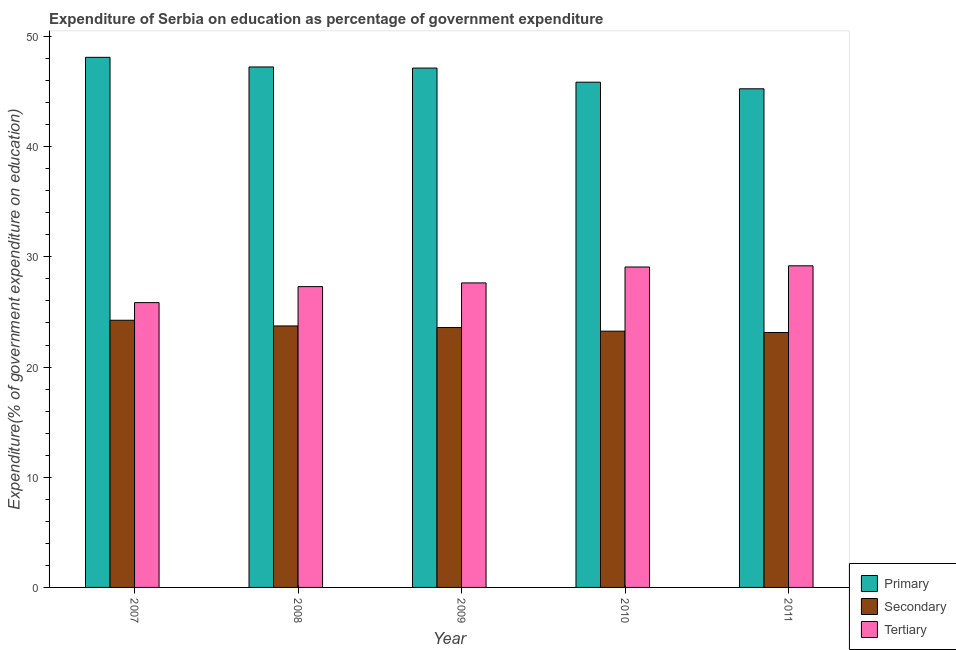How many different coloured bars are there?
Offer a very short reply. 3. Are the number of bars on each tick of the X-axis equal?
Offer a very short reply. Yes. How many bars are there on the 1st tick from the left?
Keep it short and to the point. 3. In how many cases, is the number of bars for a given year not equal to the number of legend labels?
Offer a very short reply. 0. What is the expenditure on tertiary education in 2007?
Offer a terse response. 25.85. Across all years, what is the maximum expenditure on primary education?
Your answer should be very brief. 48.11. Across all years, what is the minimum expenditure on secondary education?
Keep it short and to the point. 23.14. What is the total expenditure on tertiary education in the graph?
Your response must be concise. 139.06. What is the difference between the expenditure on tertiary education in 2008 and that in 2010?
Your answer should be very brief. -1.78. What is the difference between the expenditure on secondary education in 2011 and the expenditure on tertiary education in 2009?
Your answer should be very brief. -0.45. What is the average expenditure on primary education per year?
Offer a terse response. 46.72. In how many years, is the expenditure on secondary education greater than 38 %?
Offer a very short reply. 0. What is the ratio of the expenditure on primary education in 2007 to that in 2010?
Ensure brevity in your answer.  1.05. Is the expenditure on tertiary education in 2008 less than that in 2009?
Provide a succinct answer. Yes. Is the difference between the expenditure on secondary education in 2007 and 2011 greater than the difference between the expenditure on tertiary education in 2007 and 2011?
Keep it short and to the point. No. What is the difference between the highest and the second highest expenditure on primary education?
Keep it short and to the point. 0.87. What is the difference between the highest and the lowest expenditure on tertiary education?
Make the answer very short. 3.34. Is the sum of the expenditure on tertiary education in 2009 and 2011 greater than the maximum expenditure on secondary education across all years?
Provide a short and direct response. Yes. What does the 3rd bar from the left in 2011 represents?
Give a very brief answer. Tertiary. What does the 2nd bar from the right in 2009 represents?
Make the answer very short. Secondary. How many bars are there?
Provide a succinct answer. 15. How many years are there in the graph?
Provide a short and direct response. 5. What is the difference between two consecutive major ticks on the Y-axis?
Give a very brief answer. 10. Are the values on the major ticks of Y-axis written in scientific E-notation?
Provide a succinct answer. No. Does the graph contain any zero values?
Make the answer very short. No. Does the graph contain grids?
Your response must be concise. No. What is the title of the graph?
Keep it short and to the point. Expenditure of Serbia on education as percentage of government expenditure. What is the label or title of the X-axis?
Offer a terse response. Year. What is the label or title of the Y-axis?
Provide a short and direct response. Expenditure(% of government expenditure on education). What is the Expenditure(% of government expenditure on education) in Primary in 2007?
Your answer should be compact. 48.11. What is the Expenditure(% of government expenditure on education) in Secondary in 2007?
Ensure brevity in your answer.  24.25. What is the Expenditure(% of government expenditure on education) in Tertiary in 2007?
Your answer should be compact. 25.85. What is the Expenditure(% of government expenditure on education) of Primary in 2008?
Keep it short and to the point. 47.24. What is the Expenditure(% of government expenditure on education) in Secondary in 2008?
Provide a short and direct response. 23.73. What is the Expenditure(% of government expenditure on education) of Tertiary in 2008?
Ensure brevity in your answer.  27.3. What is the Expenditure(% of government expenditure on education) in Primary in 2009?
Your answer should be compact. 47.14. What is the Expenditure(% of government expenditure on education) of Secondary in 2009?
Your answer should be compact. 23.59. What is the Expenditure(% of government expenditure on education) in Tertiary in 2009?
Offer a terse response. 27.64. What is the Expenditure(% of government expenditure on education) in Primary in 2010?
Your answer should be very brief. 45.86. What is the Expenditure(% of government expenditure on education) of Secondary in 2010?
Give a very brief answer. 23.26. What is the Expenditure(% of government expenditure on education) of Tertiary in 2010?
Offer a terse response. 29.08. What is the Expenditure(% of government expenditure on education) of Primary in 2011?
Make the answer very short. 45.26. What is the Expenditure(% of government expenditure on education) in Secondary in 2011?
Provide a succinct answer. 23.14. What is the Expenditure(% of government expenditure on education) of Tertiary in 2011?
Offer a terse response. 29.19. Across all years, what is the maximum Expenditure(% of government expenditure on education) of Primary?
Provide a succinct answer. 48.11. Across all years, what is the maximum Expenditure(% of government expenditure on education) in Secondary?
Provide a short and direct response. 24.25. Across all years, what is the maximum Expenditure(% of government expenditure on education) of Tertiary?
Your response must be concise. 29.19. Across all years, what is the minimum Expenditure(% of government expenditure on education) in Primary?
Offer a very short reply. 45.26. Across all years, what is the minimum Expenditure(% of government expenditure on education) in Secondary?
Offer a terse response. 23.14. Across all years, what is the minimum Expenditure(% of government expenditure on education) in Tertiary?
Provide a short and direct response. 25.85. What is the total Expenditure(% of government expenditure on education) of Primary in the graph?
Provide a succinct answer. 233.6. What is the total Expenditure(% of government expenditure on education) of Secondary in the graph?
Provide a short and direct response. 117.96. What is the total Expenditure(% of government expenditure on education) in Tertiary in the graph?
Provide a succinct answer. 139.06. What is the difference between the Expenditure(% of government expenditure on education) in Primary in 2007 and that in 2008?
Give a very brief answer. 0.87. What is the difference between the Expenditure(% of government expenditure on education) of Secondary in 2007 and that in 2008?
Offer a terse response. 0.52. What is the difference between the Expenditure(% of government expenditure on education) of Tertiary in 2007 and that in 2008?
Offer a terse response. -1.45. What is the difference between the Expenditure(% of government expenditure on education) of Primary in 2007 and that in 2009?
Your response must be concise. 0.98. What is the difference between the Expenditure(% of government expenditure on education) in Secondary in 2007 and that in 2009?
Provide a succinct answer. 0.66. What is the difference between the Expenditure(% of government expenditure on education) of Tertiary in 2007 and that in 2009?
Ensure brevity in your answer.  -1.79. What is the difference between the Expenditure(% of government expenditure on education) of Primary in 2007 and that in 2010?
Offer a terse response. 2.26. What is the difference between the Expenditure(% of government expenditure on education) in Secondary in 2007 and that in 2010?
Keep it short and to the point. 0.99. What is the difference between the Expenditure(% of government expenditure on education) in Tertiary in 2007 and that in 2010?
Offer a terse response. -3.23. What is the difference between the Expenditure(% of government expenditure on education) in Primary in 2007 and that in 2011?
Your answer should be compact. 2.86. What is the difference between the Expenditure(% of government expenditure on education) of Secondary in 2007 and that in 2011?
Make the answer very short. 1.11. What is the difference between the Expenditure(% of government expenditure on education) in Tertiary in 2007 and that in 2011?
Your answer should be very brief. -3.34. What is the difference between the Expenditure(% of government expenditure on education) in Primary in 2008 and that in 2009?
Your response must be concise. 0.1. What is the difference between the Expenditure(% of government expenditure on education) in Secondary in 2008 and that in 2009?
Offer a terse response. 0.14. What is the difference between the Expenditure(% of government expenditure on education) of Tertiary in 2008 and that in 2009?
Offer a terse response. -0.34. What is the difference between the Expenditure(% of government expenditure on education) in Primary in 2008 and that in 2010?
Your answer should be very brief. 1.38. What is the difference between the Expenditure(% of government expenditure on education) in Secondary in 2008 and that in 2010?
Offer a terse response. 0.47. What is the difference between the Expenditure(% of government expenditure on education) in Tertiary in 2008 and that in 2010?
Provide a short and direct response. -1.78. What is the difference between the Expenditure(% of government expenditure on education) in Primary in 2008 and that in 2011?
Give a very brief answer. 1.98. What is the difference between the Expenditure(% of government expenditure on education) in Secondary in 2008 and that in 2011?
Ensure brevity in your answer.  0.59. What is the difference between the Expenditure(% of government expenditure on education) in Tertiary in 2008 and that in 2011?
Ensure brevity in your answer.  -1.89. What is the difference between the Expenditure(% of government expenditure on education) in Primary in 2009 and that in 2010?
Provide a short and direct response. 1.28. What is the difference between the Expenditure(% of government expenditure on education) in Secondary in 2009 and that in 2010?
Your response must be concise. 0.33. What is the difference between the Expenditure(% of government expenditure on education) in Tertiary in 2009 and that in 2010?
Your answer should be compact. -1.44. What is the difference between the Expenditure(% of government expenditure on education) in Primary in 2009 and that in 2011?
Ensure brevity in your answer.  1.88. What is the difference between the Expenditure(% of government expenditure on education) in Secondary in 2009 and that in 2011?
Provide a short and direct response. 0.45. What is the difference between the Expenditure(% of government expenditure on education) of Tertiary in 2009 and that in 2011?
Provide a succinct answer. -1.55. What is the difference between the Expenditure(% of government expenditure on education) in Primary in 2010 and that in 2011?
Provide a short and direct response. 0.6. What is the difference between the Expenditure(% of government expenditure on education) in Secondary in 2010 and that in 2011?
Provide a succinct answer. 0.12. What is the difference between the Expenditure(% of government expenditure on education) of Tertiary in 2010 and that in 2011?
Your response must be concise. -0.11. What is the difference between the Expenditure(% of government expenditure on education) of Primary in 2007 and the Expenditure(% of government expenditure on education) of Secondary in 2008?
Offer a terse response. 24.38. What is the difference between the Expenditure(% of government expenditure on education) in Primary in 2007 and the Expenditure(% of government expenditure on education) in Tertiary in 2008?
Keep it short and to the point. 20.81. What is the difference between the Expenditure(% of government expenditure on education) of Secondary in 2007 and the Expenditure(% of government expenditure on education) of Tertiary in 2008?
Your answer should be very brief. -3.05. What is the difference between the Expenditure(% of government expenditure on education) of Primary in 2007 and the Expenditure(% of government expenditure on education) of Secondary in 2009?
Keep it short and to the point. 24.52. What is the difference between the Expenditure(% of government expenditure on education) of Primary in 2007 and the Expenditure(% of government expenditure on education) of Tertiary in 2009?
Your response must be concise. 20.47. What is the difference between the Expenditure(% of government expenditure on education) of Secondary in 2007 and the Expenditure(% of government expenditure on education) of Tertiary in 2009?
Provide a short and direct response. -3.39. What is the difference between the Expenditure(% of government expenditure on education) of Primary in 2007 and the Expenditure(% of government expenditure on education) of Secondary in 2010?
Your response must be concise. 24.85. What is the difference between the Expenditure(% of government expenditure on education) in Primary in 2007 and the Expenditure(% of government expenditure on education) in Tertiary in 2010?
Keep it short and to the point. 19.03. What is the difference between the Expenditure(% of government expenditure on education) of Secondary in 2007 and the Expenditure(% of government expenditure on education) of Tertiary in 2010?
Offer a terse response. -4.83. What is the difference between the Expenditure(% of government expenditure on education) of Primary in 2007 and the Expenditure(% of government expenditure on education) of Secondary in 2011?
Keep it short and to the point. 24.97. What is the difference between the Expenditure(% of government expenditure on education) of Primary in 2007 and the Expenditure(% of government expenditure on education) of Tertiary in 2011?
Your answer should be compact. 18.92. What is the difference between the Expenditure(% of government expenditure on education) of Secondary in 2007 and the Expenditure(% of government expenditure on education) of Tertiary in 2011?
Provide a succinct answer. -4.94. What is the difference between the Expenditure(% of government expenditure on education) in Primary in 2008 and the Expenditure(% of government expenditure on education) in Secondary in 2009?
Make the answer very short. 23.65. What is the difference between the Expenditure(% of government expenditure on education) of Primary in 2008 and the Expenditure(% of government expenditure on education) of Tertiary in 2009?
Provide a short and direct response. 19.6. What is the difference between the Expenditure(% of government expenditure on education) in Secondary in 2008 and the Expenditure(% of government expenditure on education) in Tertiary in 2009?
Ensure brevity in your answer.  -3.91. What is the difference between the Expenditure(% of government expenditure on education) in Primary in 2008 and the Expenditure(% of government expenditure on education) in Secondary in 2010?
Ensure brevity in your answer.  23.98. What is the difference between the Expenditure(% of government expenditure on education) of Primary in 2008 and the Expenditure(% of government expenditure on education) of Tertiary in 2010?
Your response must be concise. 18.16. What is the difference between the Expenditure(% of government expenditure on education) in Secondary in 2008 and the Expenditure(% of government expenditure on education) in Tertiary in 2010?
Make the answer very short. -5.35. What is the difference between the Expenditure(% of government expenditure on education) in Primary in 2008 and the Expenditure(% of government expenditure on education) in Secondary in 2011?
Provide a succinct answer. 24.1. What is the difference between the Expenditure(% of government expenditure on education) of Primary in 2008 and the Expenditure(% of government expenditure on education) of Tertiary in 2011?
Your answer should be very brief. 18.05. What is the difference between the Expenditure(% of government expenditure on education) of Secondary in 2008 and the Expenditure(% of government expenditure on education) of Tertiary in 2011?
Offer a terse response. -5.46. What is the difference between the Expenditure(% of government expenditure on education) in Primary in 2009 and the Expenditure(% of government expenditure on education) in Secondary in 2010?
Provide a short and direct response. 23.88. What is the difference between the Expenditure(% of government expenditure on education) of Primary in 2009 and the Expenditure(% of government expenditure on education) of Tertiary in 2010?
Provide a succinct answer. 18.05. What is the difference between the Expenditure(% of government expenditure on education) of Secondary in 2009 and the Expenditure(% of government expenditure on education) of Tertiary in 2010?
Keep it short and to the point. -5.49. What is the difference between the Expenditure(% of government expenditure on education) of Primary in 2009 and the Expenditure(% of government expenditure on education) of Secondary in 2011?
Make the answer very short. 24. What is the difference between the Expenditure(% of government expenditure on education) of Primary in 2009 and the Expenditure(% of government expenditure on education) of Tertiary in 2011?
Ensure brevity in your answer.  17.95. What is the difference between the Expenditure(% of government expenditure on education) in Secondary in 2009 and the Expenditure(% of government expenditure on education) in Tertiary in 2011?
Give a very brief answer. -5.6. What is the difference between the Expenditure(% of government expenditure on education) in Primary in 2010 and the Expenditure(% of government expenditure on education) in Secondary in 2011?
Ensure brevity in your answer.  22.72. What is the difference between the Expenditure(% of government expenditure on education) in Primary in 2010 and the Expenditure(% of government expenditure on education) in Tertiary in 2011?
Provide a short and direct response. 16.66. What is the difference between the Expenditure(% of government expenditure on education) of Secondary in 2010 and the Expenditure(% of government expenditure on education) of Tertiary in 2011?
Provide a succinct answer. -5.93. What is the average Expenditure(% of government expenditure on education) in Primary per year?
Ensure brevity in your answer.  46.72. What is the average Expenditure(% of government expenditure on education) in Secondary per year?
Your answer should be very brief. 23.59. What is the average Expenditure(% of government expenditure on education) in Tertiary per year?
Offer a terse response. 27.81. In the year 2007, what is the difference between the Expenditure(% of government expenditure on education) of Primary and Expenditure(% of government expenditure on education) of Secondary?
Give a very brief answer. 23.86. In the year 2007, what is the difference between the Expenditure(% of government expenditure on education) in Primary and Expenditure(% of government expenditure on education) in Tertiary?
Offer a terse response. 22.26. In the year 2007, what is the difference between the Expenditure(% of government expenditure on education) of Secondary and Expenditure(% of government expenditure on education) of Tertiary?
Your response must be concise. -1.6. In the year 2008, what is the difference between the Expenditure(% of government expenditure on education) in Primary and Expenditure(% of government expenditure on education) in Secondary?
Provide a succinct answer. 23.51. In the year 2008, what is the difference between the Expenditure(% of government expenditure on education) of Primary and Expenditure(% of government expenditure on education) of Tertiary?
Your response must be concise. 19.94. In the year 2008, what is the difference between the Expenditure(% of government expenditure on education) of Secondary and Expenditure(% of government expenditure on education) of Tertiary?
Keep it short and to the point. -3.57. In the year 2009, what is the difference between the Expenditure(% of government expenditure on education) in Primary and Expenditure(% of government expenditure on education) in Secondary?
Your response must be concise. 23.55. In the year 2009, what is the difference between the Expenditure(% of government expenditure on education) in Primary and Expenditure(% of government expenditure on education) in Tertiary?
Offer a terse response. 19.5. In the year 2009, what is the difference between the Expenditure(% of government expenditure on education) in Secondary and Expenditure(% of government expenditure on education) in Tertiary?
Give a very brief answer. -4.05. In the year 2010, what is the difference between the Expenditure(% of government expenditure on education) of Primary and Expenditure(% of government expenditure on education) of Secondary?
Your response must be concise. 22.6. In the year 2010, what is the difference between the Expenditure(% of government expenditure on education) in Primary and Expenditure(% of government expenditure on education) in Tertiary?
Provide a succinct answer. 16.77. In the year 2010, what is the difference between the Expenditure(% of government expenditure on education) in Secondary and Expenditure(% of government expenditure on education) in Tertiary?
Your answer should be compact. -5.82. In the year 2011, what is the difference between the Expenditure(% of government expenditure on education) of Primary and Expenditure(% of government expenditure on education) of Secondary?
Offer a very short reply. 22.12. In the year 2011, what is the difference between the Expenditure(% of government expenditure on education) in Primary and Expenditure(% of government expenditure on education) in Tertiary?
Your answer should be very brief. 16.07. In the year 2011, what is the difference between the Expenditure(% of government expenditure on education) in Secondary and Expenditure(% of government expenditure on education) in Tertiary?
Ensure brevity in your answer.  -6.05. What is the ratio of the Expenditure(% of government expenditure on education) of Primary in 2007 to that in 2008?
Make the answer very short. 1.02. What is the ratio of the Expenditure(% of government expenditure on education) in Secondary in 2007 to that in 2008?
Give a very brief answer. 1.02. What is the ratio of the Expenditure(% of government expenditure on education) in Tertiary in 2007 to that in 2008?
Give a very brief answer. 0.95. What is the ratio of the Expenditure(% of government expenditure on education) in Primary in 2007 to that in 2009?
Offer a very short reply. 1.02. What is the ratio of the Expenditure(% of government expenditure on education) in Secondary in 2007 to that in 2009?
Provide a short and direct response. 1.03. What is the ratio of the Expenditure(% of government expenditure on education) in Tertiary in 2007 to that in 2009?
Your answer should be very brief. 0.94. What is the ratio of the Expenditure(% of government expenditure on education) in Primary in 2007 to that in 2010?
Provide a succinct answer. 1.05. What is the ratio of the Expenditure(% of government expenditure on education) in Secondary in 2007 to that in 2010?
Provide a short and direct response. 1.04. What is the ratio of the Expenditure(% of government expenditure on education) of Tertiary in 2007 to that in 2010?
Your response must be concise. 0.89. What is the ratio of the Expenditure(% of government expenditure on education) in Primary in 2007 to that in 2011?
Your response must be concise. 1.06. What is the ratio of the Expenditure(% of government expenditure on education) in Secondary in 2007 to that in 2011?
Ensure brevity in your answer.  1.05. What is the ratio of the Expenditure(% of government expenditure on education) of Tertiary in 2007 to that in 2011?
Offer a very short reply. 0.89. What is the ratio of the Expenditure(% of government expenditure on education) in Tertiary in 2008 to that in 2009?
Give a very brief answer. 0.99. What is the ratio of the Expenditure(% of government expenditure on education) of Primary in 2008 to that in 2010?
Offer a terse response. 1.03. What is the ratio of the Expenditure(% of government expenditure on education) in Secondary in 2008 to that in 2010?
Provide a short and direct response. 1.02. What is the ratio of the Expenditure(% of government expenditure on education) in Tertiary in 2008 to that in 2010?
Give a very brief answer. 0.94. What is the ratio of the Expenditure(% of government expenditure on education) of Primary in 2008 to that in 2011?
Ensure brevity in your answer.  1.04. What is the ratio of the Expenditure(% of government expenditure on education) of Secondary in 2008 to that in 2011?
Offer a very short reply. 1.03. What is the ratio of the Expenditure(% of government expenditure on education) in Tertiary in 2008 to that in 2011?
Provide a short and direct response. 0.94. What is the ratio of the Expenditure(% of government expenditure on education) in Primary in 2009 to that in 2010?
Keep it short and to the point. 1.03. What is the ratio of the Expenditure(% of government expenditure on education) of Secondary in 2009 to that in 2010?
Provide a succinct answer. 1.01. What is the ratio of the Expenditure(% of government expenditure on education) of Tertiary in 2009 to that in 2010?
Your response must be concise. 0.95. What is the ratio of the Expenditure(% of government expenditure on education) of Primary in 2009 to that in 2011?
Ensure brevity in your answer.  1.04. What is the ratio of the Expenditure(% of government expenditure on education) of Secondary in 2009 to that in 2011?
Keep it short and to the point. 1.02. What is the ratio of the Expenditure(% of government expenditure on education) of Tertiary in 2009 to that in 2011?
Give a very brief answer. 0.95. What is the ratio of the Expenditure(% of government expenditure on education) in Primary in 2010 to that in 2011?
Ensure brevity in your answer.  1.01. What is the difference between the highest and the second highest Expenditure(% of government expenditure on education) in Primary?
Your answer should be very brief. 0.87. What is the difference between the highest and the second highest Expenditure(% of government expenditure on education) of Secondary?
Keep it short and to the point. 0.52. What is the difference between the highest and the second highest Expenditure(% of government expenditure on education) of Tertiary?
Offer a terse response. 0.11. What is the difference between the highest and the lowest Expenditure(% of government expenditure on education) in Primary?
Offer a very short reply. 2.86. What is the difference between the highest and the lowest Expenditure(% of government expenditure on education) in Secondary?
Provide a short and direct response. 1.11. What is the difference between the highest and the lowest Expenditure(% of government expenditure on education) of Tertiary?
Your response must be concise. 3.34. 